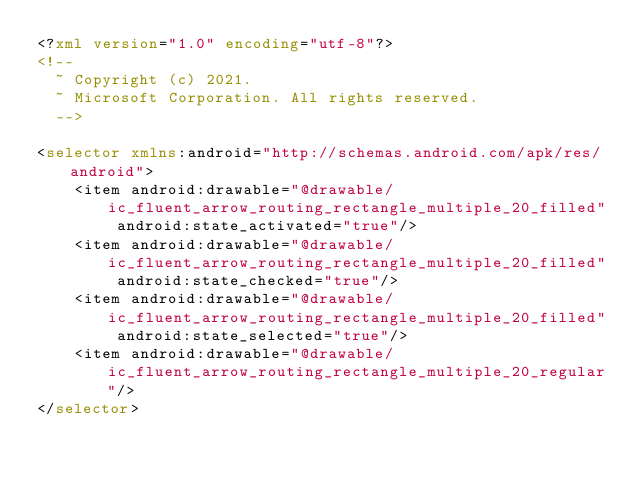<code> <loc_0><loc_0><loc_500><loc_500><_XML_><?xml version="1.0" encoding="utf-8"?>
<!--
  ~ Copyright (c) 2021.
  ~ Microsoft Corporation. All rights reserved.
  -->

<selector xmlns:android="http://schemas.android.com/apk/res/android">
    <item android:drawable="@drawable/ic_fluent_arrow_routing_rectangle_multiple_20_filled" android:state_activated="true"/>
    <item android:drawable="@drawable/ic_fluent_arrow_routing_rectangle_multiple_20_filled" android:state_checked="true"/>
    <item android:drawable="@drawable/ic_fluent_arrow_routing_rectangle_multiple_20_filled" android:state_selected="true"/>
    <item android:drawable="@drawable/ic_fluent_arrow_routing_rectangle_multiple_20_regular"/>
</selector>
</code> 